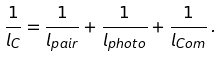Convert formula to latex. <formula><loc_0><loc_0><loc_500><loc_500>\frac { 1 } { l _ { C } } = \frac { 1 } { l _ { p a i r } } + \frac { 1 } { l _ { p h o t o } } + \frac { 1 } { l _ { C o m } } \, .</formula> 